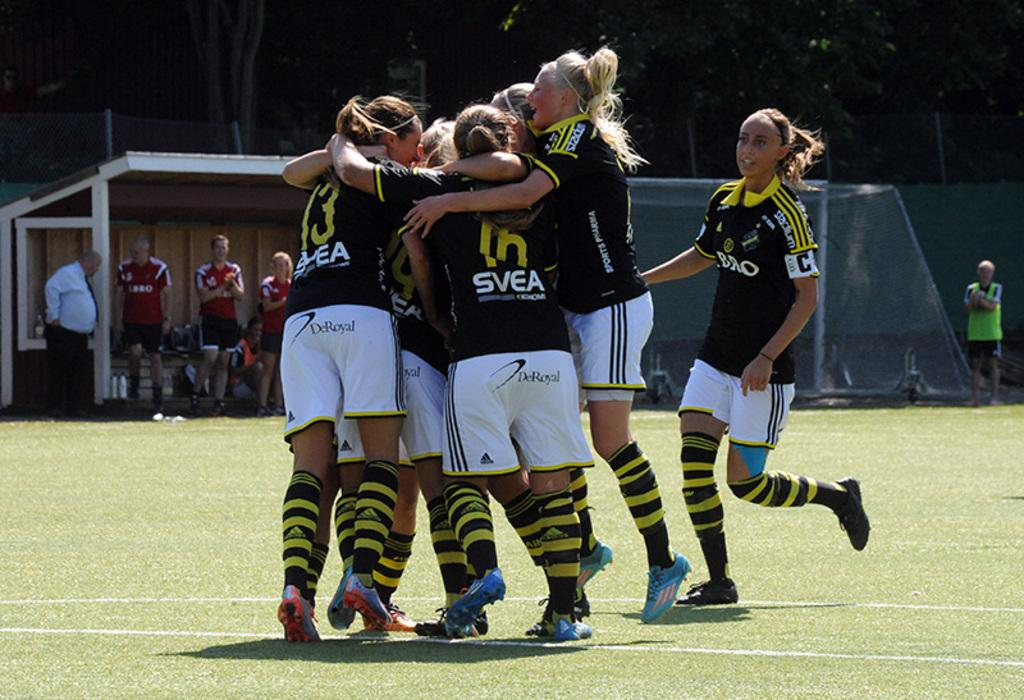How many people are in the image? There are a few people in the image. What is the ground covered with? The ground is covered with grass. What can be seen in the image that might be used for playing a game? There is a net visible in the image. What type of structure is present in the image? There is a shed in the image. What type of barrier is present in the image? There is a fence in the image. What type of vegetation is present in the image? There are trees in the image. What type of coil is used to stir the trees in the image? There is no coil present in the image, and trees do not require stirring. What time of day is it in the image, given the presence of a spoon? There is no spoon present in the image, and the time of day cannot be determined from the image alone. 